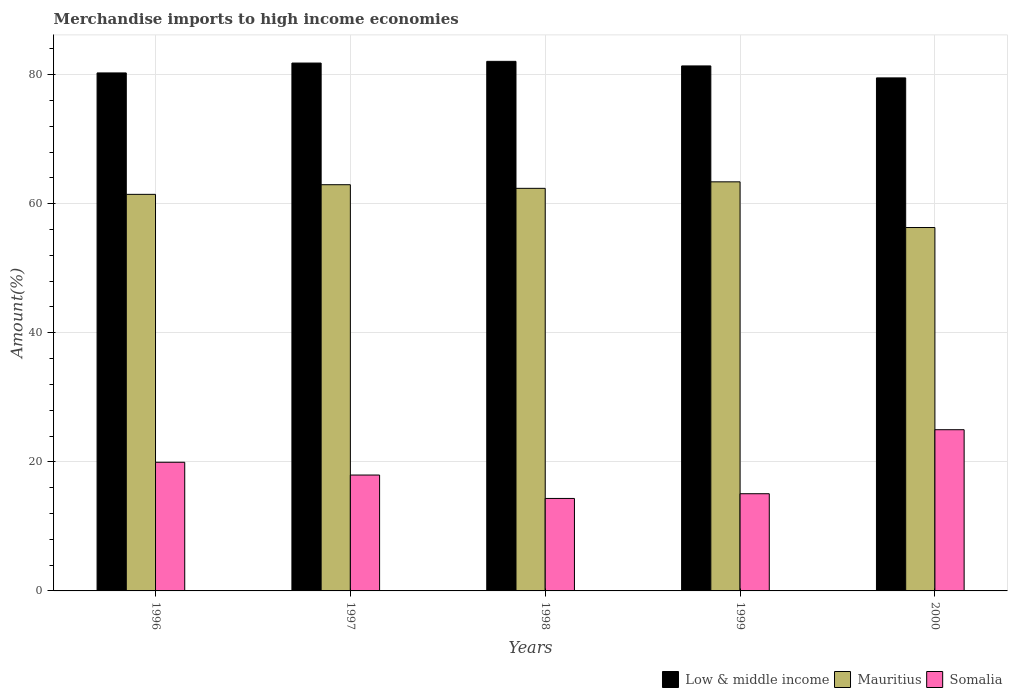How many different coloured bars are there?
Your answer should be compact. 3. Are the number of bars per tick equal to the number of legend labels?
Make the answer very short. Yes. In how many cases, is the number of bars for a given year not equal to the number of legend labels?
Make the answer very short. 0. What is the percentage of amount earned from merchandise imports in Mauritius in 2000?
Make the answer very short. 56.31. Across all years, what is the maximum percentage of amount earned from merchandise imports in Low & middle income?
Ensure brevity in your answer.  82.05. Across all years, what is the minimum percentage of amount earned from merchandise imports in Low & middle income?
Your answer should be compact. 79.49. In which year was the percentage of amount earned from merchandise imports in Somalia minimum?
Ensure brevity in your answer.  1998. What is the total percentage of amount earned from merchandise imports in Low & middle income in the graph?
Give a very brief answer. 404.94. What is the difference between the percentage of amount earned from merchandise imports in Somalia in 1996 and that in 1999?
Offer a very short reply. 4.88. What is the difference between the percentage of amount earned from merchandise imports in Mauritius in 1997 and the percentage of amount earned from merchandise imports in Somalia in 1996?
Make the answer very short. 43. What is the average percentage of amount earned from merchandise imports in Mauritius per year?
Ensure brevity in your answer.  61.29. In the year 1996, what is the difference between the percentage of amount earned from merchandise imports in Low & middle income and percentage of amount earned from merchandise imports in Mauritius?
Give a very brief answer. 18.81. In how many years, is the percentage of amount earned from merchandise imports in Low & middle income greater than 24 %?
Provide a succinct answer. 5. What is the ratio of the percentage of amount earned from merchandise imports in Low & middle income in 1996 to that in 1998?
Give a very brief answer. 0.98. Is the difference between the percentage of amount earned from merchandise imports in Low & middle income in 1996 and 1997 greater than the difference between the percentage of amount earned from merchandise imports in Mauritius in 1996 and 1997?
Offer a very short reply. No. What is the difference between the highest and the second highest percentage of amount earned from merchandise imports in Low & middle income?
Keep it short and to the point. 0.26. What is the difference between the highest and the lowest percentage of amount earned from merchandise imports in Low & middle income?
Provide a short and direct response. 2.56. In how many years, is the percentage of amount earned from merchandise imports in Somalia greater than the average percentage of amount earned from merchandise imports in Somalia taken over all years?
Your response must be concise. 2. Is the sum of the percentage of amount earned from merchandise imports in Low & middle income in 1997 and 1998 greater than the maximum percentage of amount earned from merchandise imports in Mauritius across all years?
Offer a terse response. Yes. What does the 2nd bar from the left in 1996 represents?
Your response must be concise. Mauritius. What does the 2nd bar from the right in 1996 represents?
Provide a succinct answer. Mauritius. Is it the case that in every year, the sum of the percentage of amount earned from merchandise imports in Somalia and percentage of amount earned from merchandise imports in Mauritius is greater than the percentage of amount earned from merchandise imports in Low & middle income?
Offer a very short reply. No. Are all the bars in the graph horizontal?
Provide a short and direct response. No. What is the difference between two consecutive major ticks on the Y-axis?
Give a very brief answer. 20. Are the values on the major ticks of Y-axis written in scientific E-notation?
Keep it short and to the point. No. Does the graph contain any zero values?
Offer a terse response. No. Does the graph contain grids?
Provide a short and direct response. Yes. Where does the legend appear in the graph?
Your answer should be very brief. Bottom right. How many legend labels are there?
Provide a short and direct response. 3. What is the title of the graph?
Ensure brevity in your answer.  Merchandise imports to high income economies. What is the label or title of the Y-axis?
Offer a very short reply. Amount(%). What is the Amount(%) of Low & middle income in 1996?
Keep it short and to the point. 80.26. What is the Amount(%) in Mauritius in 1996?
Provide a succinct answer. 61.45. What is the Amount(%) in Somalia in 1996?
Offer a very short reply. 19.94. What is the Amount(%) of Low & middle income in 1997?
Offer a very short reply. 81.79. What is the Amount(%) in Mauritius in 1997?
Your response must be concise. 62.94. What is the Amount(%) of Somalia in 1997?
Provide a short and direct response. 17.96. What is the Amount(%) in Low & middle income in 1998?
Provide a short and direct response. 82.05. What is the Amount(%) of Mauritius in 1998?
Offer a terse response. 62.38. What is the Amount(%) of Somalia in 1998?
Give a very brief answer. 14.33. What is the Amount(%) of Low & middle income in 1999?
Your answer should be compact. 81.35. What is the Amount(%) in Mauritius in 1999?
Provide a succinct answer. 63.38. What is the Amount(%) in Somalia in 1999?
Make the answer very short. 15.06. What is the Amount(%) in Low & middle income in 2000?
Your answer should be compact. 79.49. What is the Amount(%) in Mauritius in 2000?
Provide a short and direct response. 56.31. What is the Amount(%) in Somalia in 2000?
Ensure brevity in your answer.  24.98. Across all years, what is the maximum Amount(%) in Low & middle income?
Offer a terse response. 82.05. Across all years, what is the maximum Amount(%) in Mauritius?
Your response must be concise. 63.38. Across all years, what is the maximum Amount(%) in Somalia?
Make the answer very short. 24.98. Across all years, what is the minimum Amount(%) of Low & middle income?
Give a very brief answer. 79.49. Across all years, what is the minimum Amount(%) of Mauritius?
Your answer should be compact. 56.31. Across all years, what is the minimum Amount(%) of Somalia?
Your answer should be compact. 14.33. What is the total Amount(%) of Low & middle income in the graph?
Provide a succinct answer. 404.94. What is the total Amount(%) of Mauritius in the graph?
Keep it short and to the point. 306.46. What is the total Amount(%) of Somalia in the graph?
Your response must be concise. 92.26. What is the difference between the Amount(%) in Low & middle income in 1996 and that in 1997?
Offer a terse response. -1.53. What is the difference between the Amount(%) of Mauritius in 1996 and that in 1997?
Offer a terse response. -1.49. What is the difference between the Amount(%) of Somalia in 1996 and that in 1997?
Provide a short and direct response. 1.98. What is the difference between the Amount(%) in Low & middle income in 1996 and that in 1998?
Provide a succinct answer. -1.79. What is the difference between the Amount(%) of Mauritius in 1996 and that in 1998?
Provide a short and direct response. -0.93. What is the difference between the Amount(%) in Somalia in 1996 and that in 1998?
Offer a terse response. 5.61. What is the difference between the Amount(%) of Low & middle income in 1996 and that in 1999?
Keep it short and to the point. -1.09. What is the difference between the Amount(%) in Mauritius in 1996 and that in 1999?
Your response must be concise. -1.94. What is the difference between the Amount(%) in Somalia in 1996 and that in 1999?
Your response must be concise. 4.88. What is the difference between the Amount(%) of Low & middle income in 1996 and that in 2000?
Offer a very short reply. 0.77. What is the difference between the Amount(%) in Mauritius in 1996 and that in 2000?
Provide a succinct answer. 5.14. What is the difference between the Amount(%) of Somalia in 1996 and that in 2000?
Your answer should be compact. -5.04. What is the difference between the Amount(%) in Low & middle income in 1997 and that in 1998?
Keep it short and to the point. -0.26. What is the difference between the Amount(%) of Mauritius in 1997 and that in 1998?
Offer a terse response. 0.56. What is the difference between the Amount(%) in Somalia in 1997 and that in 1998?
Offer a terse response. 3.63. What is the difference between the Amount(%) in Low & middle income in 1997 and that in 1999?
Offer a very short reply. 0.45. What is the difference between the Amount(%) in Mauritius in 1997 and that in 1999?
Provide a succinct answer. -0.44. What is the difference between the Amount(%) in Somalia in 1997 and that in 1999?
Provide a short and direct response. 2.9. What is the difference between the Amount(%) in Low & middle income in 1997 and that in 2000?
Your answer should be very brief. 2.3. What is the difference between the Amount(%) in Mauritius in 1997 and that in 2000?
Ensure brevity in your answer.  6.63. What is the difference between the Amount(%) in Somalia in 1997 and that in 2000?
Offer a terse response. -7.02. What is the difference between the Amount(%) in Low & middle income in 1998 and that in 1999?
Your response must be concise. 0.71. What is the difference between the Amount(%) in Mauritius in 1998 and that in 1999?
Make the answer very short. -1.01. What is the difference between the Amount(%) of Somalia in 1998 and that in 1999?
Offer a terse response. -0.73. What is the difference between the Amount(%) of Low & middle income in 1998 and that in 2000?
Offer a very short reply. 2.56. What is the difference between the Amount(%) of Mauritius in 1998 and that in 2000?
Your response must be concise. 6.07. What is the difference between the Amount(%) of Somalia in 1998 and that in 2000?
Give a very brief answer. -10.65. What is the difference between the Amount(%) of Low & middle income in 1999 and that in 2000?
Ensure brevity in your answer.  1.85. What is the difference between the Amount(%) in Mauritius in 1999 and that in 2000?
Offer a terse response. 7.08. What is the difference between the Amount(%) in Somalia in 1999 and that in 2000?
Provide a succinct answer. -9.92. What is the difference between the Amount(%) of Low & middle income in 1996 and the Amount(%) of Mauritius in 1997?
Keep it short and to the point. 17.32. What is the difference between the Amount(%) of Low & middle income in 1996 and the Amount(%) of Somalia in 1997?
Offer a terse response. 62.3. What is the difference between the Amount(%) of Mauritius in 1996 and the Amount(%) of Somalia in 1997?
Make the answer very short. 43.49. What is the difference between the Amount(%) of Low & middle income in 1996 and the Amount(%) of Mauritius in 1998?
Offer a terse response. 17.88. What is the difference between the Amount(%) in Low & middle income in 1996 and the Amount(%) in Somalia in 1998?
Your response must be concise. 65.93. What is the difference between the Amount(%) of Mauritius in 1996 and the Amount(%) of Somalia in 1998?
Offer a very short reply. 47.12. What is the difference between the Amount(%) in Low & middle income in 1996 and the Amount(%) in Mauritius in 1999?
Offer a very short reply. 16.87. What is the difference between the Amount(%) in Low & middle income in 1996 and the Amount(%) in Somalia in 1999?
Your response must be concise. 65.2. What is the difference between the Amount(%) in Mauritius in 1996 and the Amount(%) in Somalia in 1999?
Give a very brief answer. 46.39. What is the difference between the Amount(%) in Low & middle income in 1996 and the Amount(%) in Mauritius in 2000?
Ensure brevity in your answer.  23.95. What is the difference between the Amount(%) of Low & middle income in 1996 and the Amount(%) of Somalia in 2000?
Offer a very short reply. 55.28. What is the difference between the Amount(%) in Mauritius in 1996 and the Amount(%) in Somalia in 2000?
Give a very brief answer. 36.47. What is the difference between the Amount(%) of Low & middle income in 1997 and the Amount(%) of Mauritius in 1998?
Your answer should be compact. 19.41. What is the difference between the Amount(%) in Low & middle income in 1997 and the Amount(%) in Somalia in 1998?
Provide a succinct answer. 67.46. What is the difference between the Amount(%) of Mauritius in 1997 and the Amount(%) of Somalia in 1998?
Make the answer very short. 48.61. What is the difference between the Amount(%) of Low & middle income in 1997 and the Amount(%) of Mauritius in 1999?
Your answer should be very brief. 18.41. What is the difference between the Amount(%) in Low & middle income in 1997 and the Amount(%) in Somalia in 1999?
Your response must be concise. 66.73. What is the difference between the Amount(%) of Mauritius in 1997 and the Amount(%) of Somalia in 1999?
Make the answer very short. 47.88. What is the difference between the Amount(%) of Low & middle income in 1997 and the Amount(%) of Mauritius in 2000?
Ensure brevity in your answer.  25.48. What is the difference between the Amount(%) in Low & middle income in 1997 and the Amount(%) in Somalia in 2000?
Your answer should be very brief. 56.81. What is the difference between the Amount(%) of Mauritius in 1997 and the Amount(%) of Somalia in 2000?
Your answer should be compact. 37.96. What is the difference between the Amount(%) of Low & middle income in 1998 and the Amount(%) of Mauritius in 1999?
Your answer should be compact. 18.67. What is the difference between the Amount(%) of Low & middle income in 1998 and the Amount(%) of Somalia in 1999?
Make the answer very short. 66.99. What is the difference between the Amount(%) of Mauritius in 1998 and the Amount(%) of Somalia in 1999?
Your answer should be very brief. 47.32. What is the difference between the Amount(%) of Low & middle income in 1998 and the Amount(%) of Mauritius in 2000?
Your answer should be compact. 25.75. What is the difference between the Amount(%) of Low & middle income in 1998 and the Amount(%) of Somalia in 2000?
Your answer should be very brief. 57.08. What is the difference between the Amount(%) in Mauritius in 1998 and the Amount(%) in Somalia in 2000?
Provide a short and direct response. 37.4. What is the difference between the Amount(%) in Low & middle income in 1999 and the Amount(%) in Mauritius in 2000?
Your answer should be compact. 25.04. What is the difference between the Amount(%) in Low & middle income in 1999 and the Amount(%) in Somalia in 2000?
Give a very brief answer. 56.37. What is the difference between the Amount(%) in Mauritius in 1999 and the Amount(%) in Somalia in 2000?
Your answer should be compact. 38.41. What is the average Amount(%) in Low & middle income per year?
Provide a short and direct response. 80.99. What is the average Amount(%) in Mauritius per year?
Give a very brief answer. 61.29. What is the average Amount(%) of Somalia per year?
Your answer should be compact. 18.45. In the year 1996, what is the difference between the Amount(%) in Low & middle income and Amount(%) in Mauritius?
Offer a terse response. 18.81. In the year 1996, what is the difference between the Amount(%) of Low & middle income and Amount(%) of Somalia?
Your response must be concise. 60.32. In the year 1996, what is the difference between the Amount(%) in Mauritius and Amount(%) in Somalia?
Offer a terse response. 41.51. In the year 1997, what is the difference between the Amount(%) in Low & middle income and Amount(%) in Mauritius?
Provide a succinct answer. 18.85. In the year 1997, what is the difference between the Amount(%) of Low & middle income and Amount(%) of Somalia?
Offer a terse response. 63.83. In the year 1997, what is the difference between the Amount(%) in Mauritius and Amount(%) in Somalia?
Your answer should be compact. 44.98. In the year 1998, what is the difference between the Amount(%) of Low & middle income and Amount(%) of Mauritius?
Offer a terse response. 19.68. In the year 1998, what is the difference between the Amount(%) of Low & middle income and Amount(%) of Somalia?
Give a very brief answer. 67.72. In the year 1998, what is the difference between the Amount(%) of Mauritius and Amount(%) of Somalia?
Offer a terse response. 48.05. In the year 1999, what is the difference between the Amount(%) in Low & middle income and Amount(%) in Mauritius?
Offer a very short reply. 17.96. In the year 1999, what is the difference between the Amount(%) of Low & middle income and Amount(%) of Somalia?
Provide a succinct answer. 66.29. In the year 1999, what is the difference between the Amount(%) in Mauritius and Amount(%) in Somalia?
Ensure brevity in your answer.  48.32. In the year 2000, what is the difference between the Amount(%) in Low & middle income and Amount(%) in Mauritius?
Offer a terse response. 23.19. In the year 2000, what is the difference between the Amount(%) in Low & middle income and Amount(%) in Somalia?
Your answer should be very brief. 54.51. In the year 2000, what is the difference between the Amount(%) in Mauritius and Amount(%) in Somalia?
Your response must be concise. 31.33. What is the ratio of the Amount(%) in Low & middle income in 1996 to that in 1997?
Your answer should be compact. 0.98. What is the ratio of the Amount(%) of Mauritius in 1996 to that in 1997?
Offer a terse response. 0.98. What is the ratio of the Amount(%) of Somalia in 1996 to that in 1997?
Offer a very short reply. 1.11. What is the ratio of the Amount(%) in Low & middle income in 1996 to that in 1998?
Provide a succinct answer. 0.98. What is the ratio of the Amount(%) of Mauritius in 1996 to that in 1998?
Your answer should be very brief. 0.99. What is the ratio of the Amount(%) of Somalia in 1996 to that in 1998?
Provide a succinct answer. 1.39. What is the ratio of the Amount(%) in Low & middle income in 1996 to that in 1999?
Ensure brevity in your answer.  0.99. What is the ratio of the Amount(%) in Mauritius in 1996 to that in 1999?
Give a very brief answer. 0.97. What is the ratio of the Amount(%) of Somalia in 1996 to that in 1999?
Provide a succinct answer. 1.32. What is the ratio of the Amount(%) of Low & middle income in 1996 to that in 2000?
Your answer should be compact. 1.01. What is the ratio of the Amount(%) of Mauritius in 1996 to that in 2000?
Ensure brevity in your answer.  1.09. What is the ratio of the Amount(%) in Somalia in 1996 to that in 2000?
Give a very brief answer. 0.8. What is the ratio of the Amount(%) of Low & middle income in 1997 to that in 1998?
Your answer should be very brief. 1. What is the ratio of the Amount(%) in Somalia in 1997 to that in 1998?
Keep it short and to the point. 1.25. What is the ratio of the Amount(%) of Low & middle income in 1997 to that in 1999?
Your answer should be compact. 1.01. What is the ratio of the Amount(%) in Somalia in 1997 to that in 1999?
Keep it short and to the point. 1.19. What is the ratio of the Amount(%) in Low & middle income in 1997 to that in 2000?
Ensure brevity in your answer.  1.03. What is the ratio of the Amount(%) of Mauritius in 1997 to that in 2000?
Your answer should be very brief. 1.12. What is the ratio of the Amount(%) of Somalia in 1997 to that in 2000?
Ensure brevity in your answer.  0.72. What is the ratio of the Amount(%) of Low & middle income in 1998 to that in 1999?
Your response must be concise. 1.01. What is the ratio of the Amount(%) of Mauritius in 1998 to that in 1999?
Your answer should be very brief. 0.98. What is the ratio of the Amount(%) in Somalia in 1998 to that in 1999?
Keep it short and to the point. 0.95. What is the ratio of the Amount(%) in Low & middle income in 1998 to that in 2000?
Ensure brevity in your answer.  1.03. What is the ratio of the Amount(%) of Mauritius in 1998 to that in 2000?
Offer a terse response. 1.11. What is the ratio of the Amount(%) of Somalia in 1998 to that in 2000?
Keep it short and to the point. 0.57. What is the ratio of the Amount(%) in Low & middle income in 1999 to that in 2000?
Offer a very short reply. 1.02. What is the ratio of the Amount(%) of Mauritius in 1999 to that in 2000?
Your answer should be compact. 1.13. What is the ratio of the Amount(%) of Somalia in 1999 to that in 2000?
Your answer should be compact. 0.6. What is the difference between the highest and the second highest Amount(%) in Low & middle income?
Ensure brevity in your answer.  0.26. What is the difference between the highest and the second highest Amount(%) of Mauritius?
Make the answer very short. 0.44. What is the difference between the highest and the second highest Amount(%) of Somalia?
Your response must be concise. 5.04. What is the difference between the highest and the lowest Amount(%) of Low & middle income?
Offer a terse response. 2.56. What is the difference between the highest and the lowest Amount(%) of Mauritius?
Provide a short and direct response. 7.08. What is the difference between the highest and the lowest Amount(%) of Somalia?
Your answer should be compact. 10.65. 